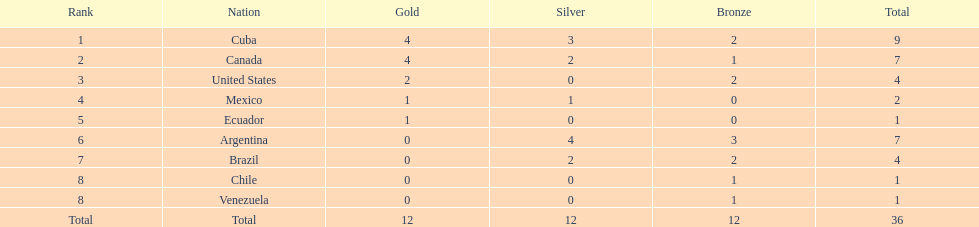Which nation obtained the largest accumulation of bronze medals? Argentina. 